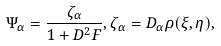Convert formula to latex. <formula><loc_0><loc_0><loc_500><loc_500>\Psi _ { \alpha } = \frac { \zeta _ { \alpha } } { 1 + D ^ { 2 } F } , \zeta _ { \alpha } = D _ { \alpha } \rho ( \xi , \eta ) ,</formula> 